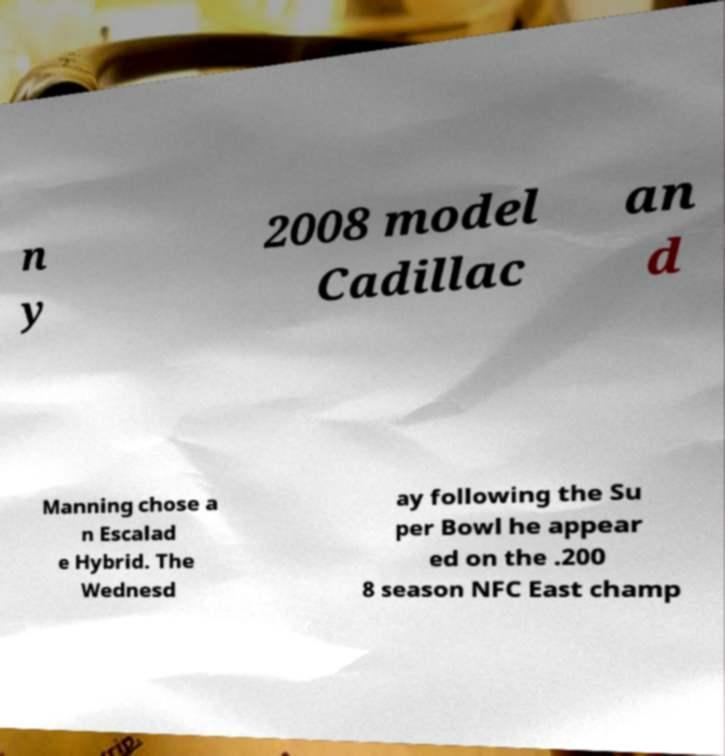Please identify and transcribe the text found in this image. n y 2008 model Cadillac an d Manning chose a n Escalad e Hybrid. The Wednesd ay following the Su per Bowl he appear ed on the .200 8 season NFC East champ 